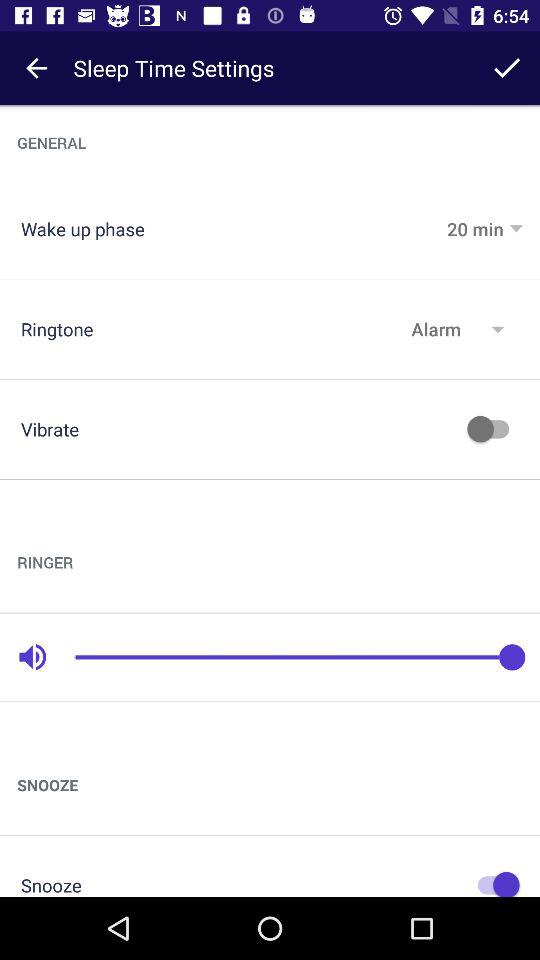What is the status of "Vibrate" setting? The status is "off". 